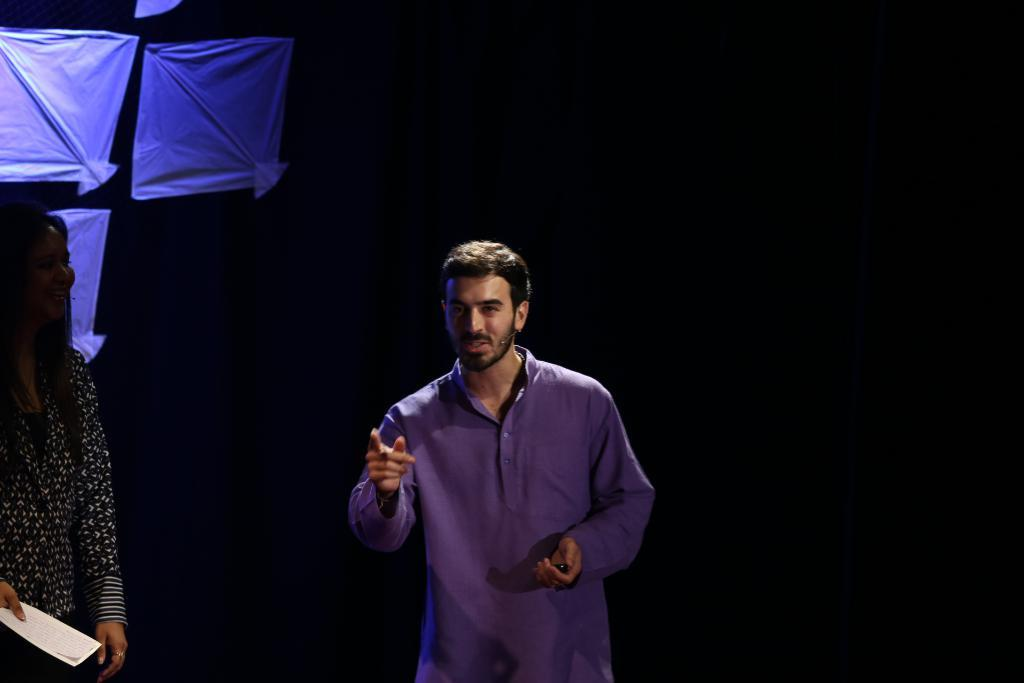What is the main subject of the image? There is a person standing in the image. Who is standing beside the person in the image? There is a lady standing beside the person in the image. What is the lady holding in her hand? The lady is holding a paper in her hand. What can be seen in the background of the image? There are kites visible in the background of the image. How would you describe the lighting in the image? The background of the image is dark. How many fingers can be seen on the person's hand in the image? There is no information about the person's fingers in the image, so it cannot be determined. What type of curve is visible in the image? There is no curve mentioned or visible in the image. 